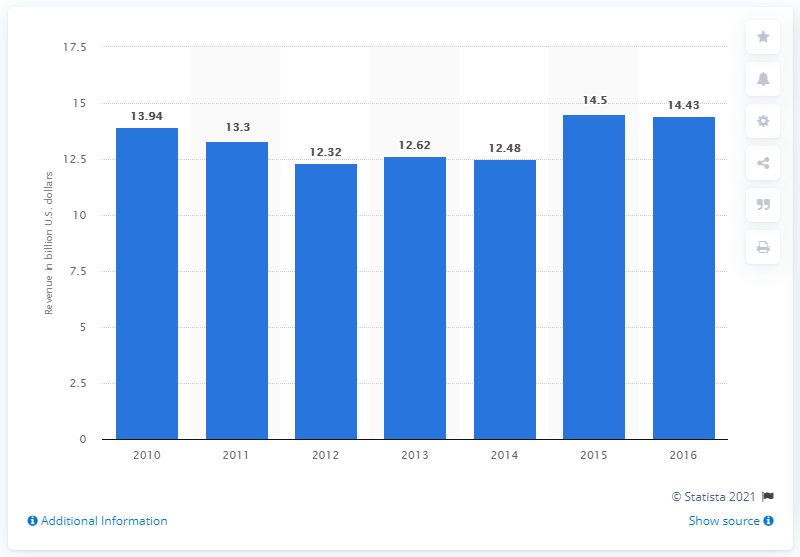Outline some significant characteristics in this image. In 2016, the estimated revenue of U.S. periodical publishers was approximately 14.43. 